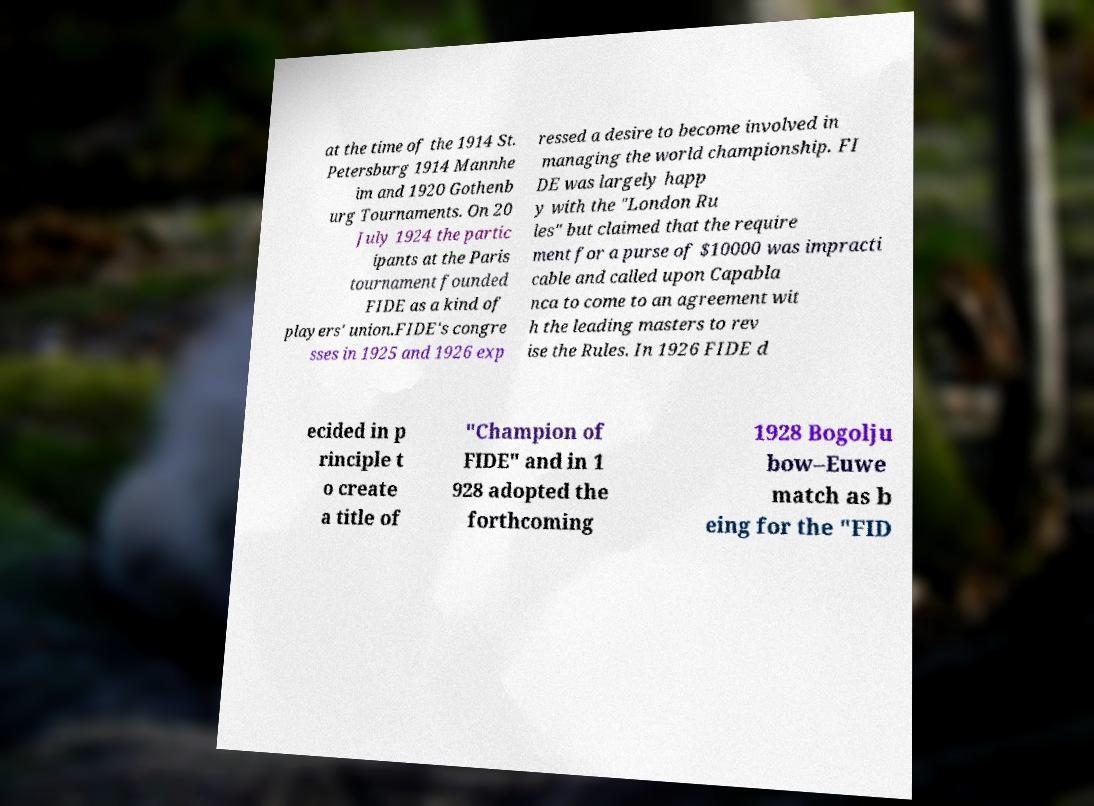Please identify and transcribe the text found in this image. at the time of the 1914 St. Petersburg 1914 Mannhe im and 1920 Gothenb urg Tournaments. On 20 July 1924 the partic ipants at the Paris tournament founded FIDE as a kind of players' union.FIDE's congre sses in 1925 and 1926 exp ressed a desire to become involved in managing the world championship. FI DE was largely happ y with the "London Ru les" but claimed that the require ment for a purse of $10000 was impracti cable and called upon Capabla nca to come to an agreement wit h the leading masters to rev ise the Rules. In 1926 FIDE d ecided in p rinciple t o create a title of "Champion of FIDE" and in 1 928 adopted the forthcoming 1928 Bogolju bow–Euwe match as b eing for the "FID 